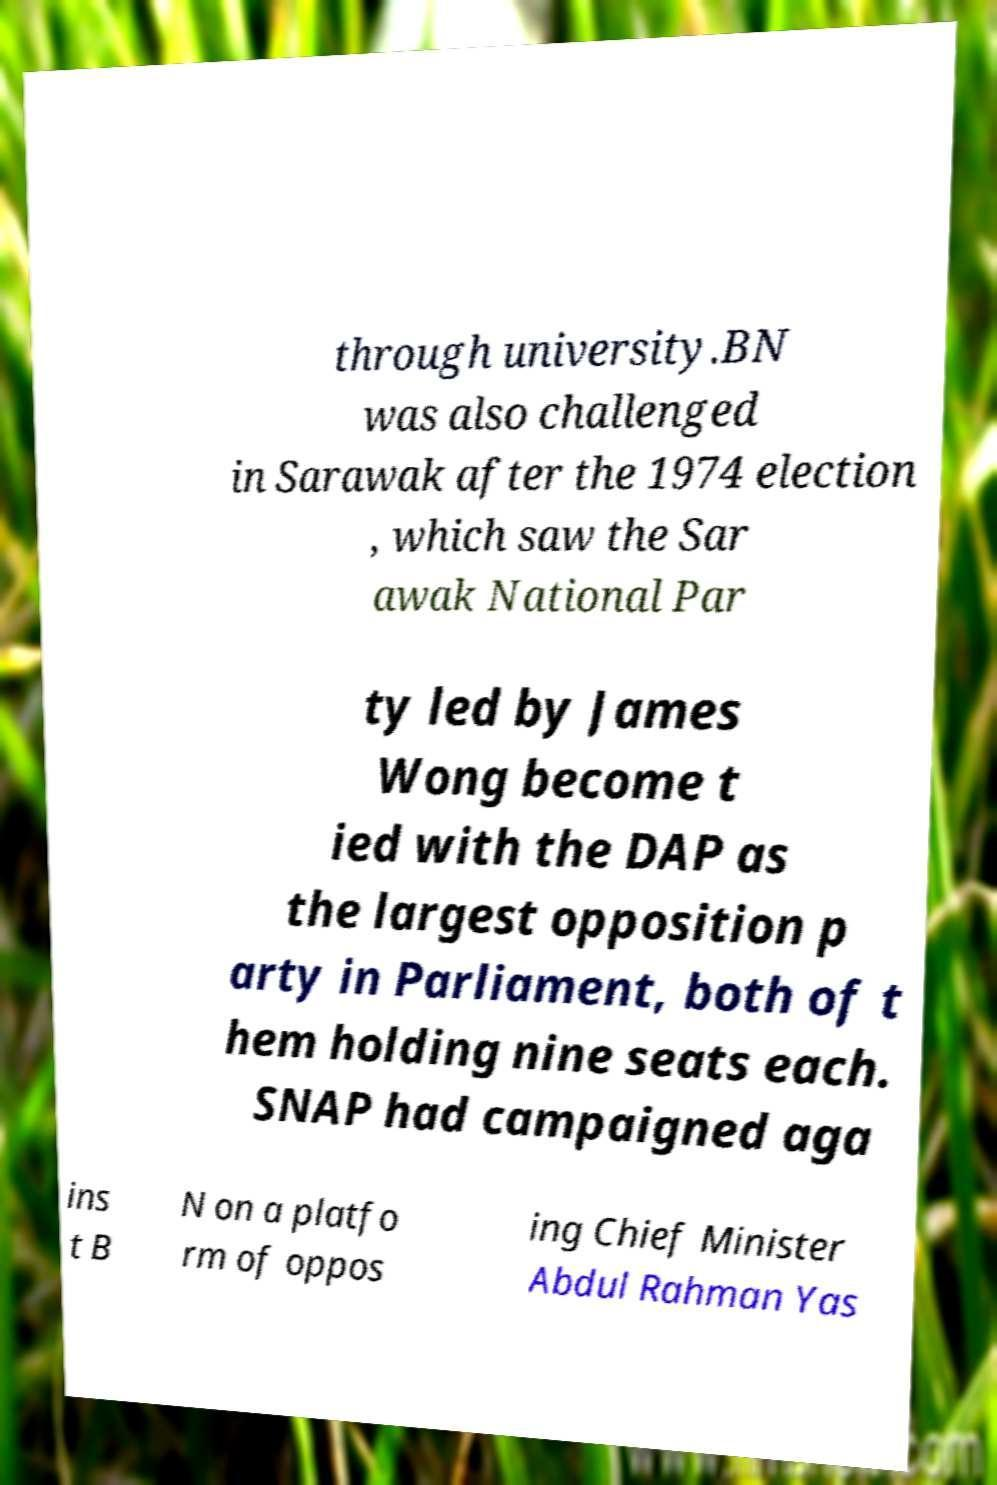Could you assist in decoding the text presented in this image and type it out clearly? through university.BN was also challenged in Sarawak after the 1974 election , which saw the Sar awak National Par ty led by James Wong become t ied with the DAP as the largest opposition p arty in Parliament, both of t hem holding nine seats each. SNAP had campaigned aga ins t B N on a platfo rm of oppos ing Chief Minister Abdul Rahman Yas 